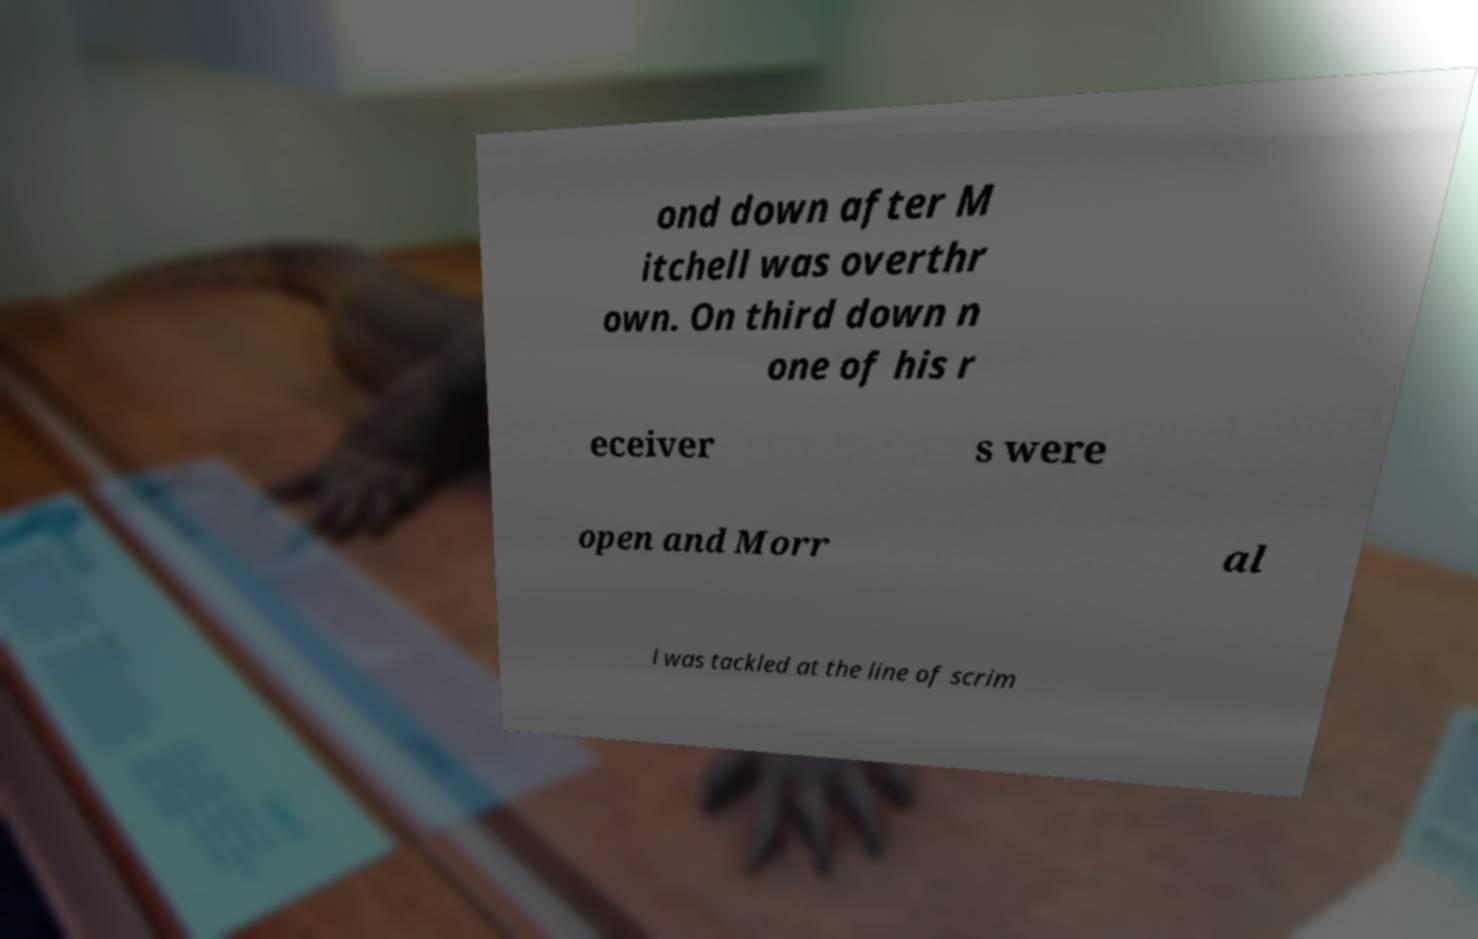Could you assist in decoding the text presented in this image and type it out clearly? ond down after M itchell was overthr own. On third down n one of his r eceiver s were open and Morr al l was tackled at the line of scrim 